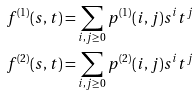<formula> <loc_0><loc_0><loc_500><loc_500>f ^ { ( 1 ) } ( s , t ) = & \sum _ { i , j \geq 0 } p ^ { ( 1 ) } ( i , j ) s ^ { i } t ^ { j } \\ f ^ { ( 2 ) } ( s , t ) = & \sum _ { i , j \geq 0 } p ^ { ( 2 ) } ( i , j ) s ^ { i } t ^ { j }</formula> 